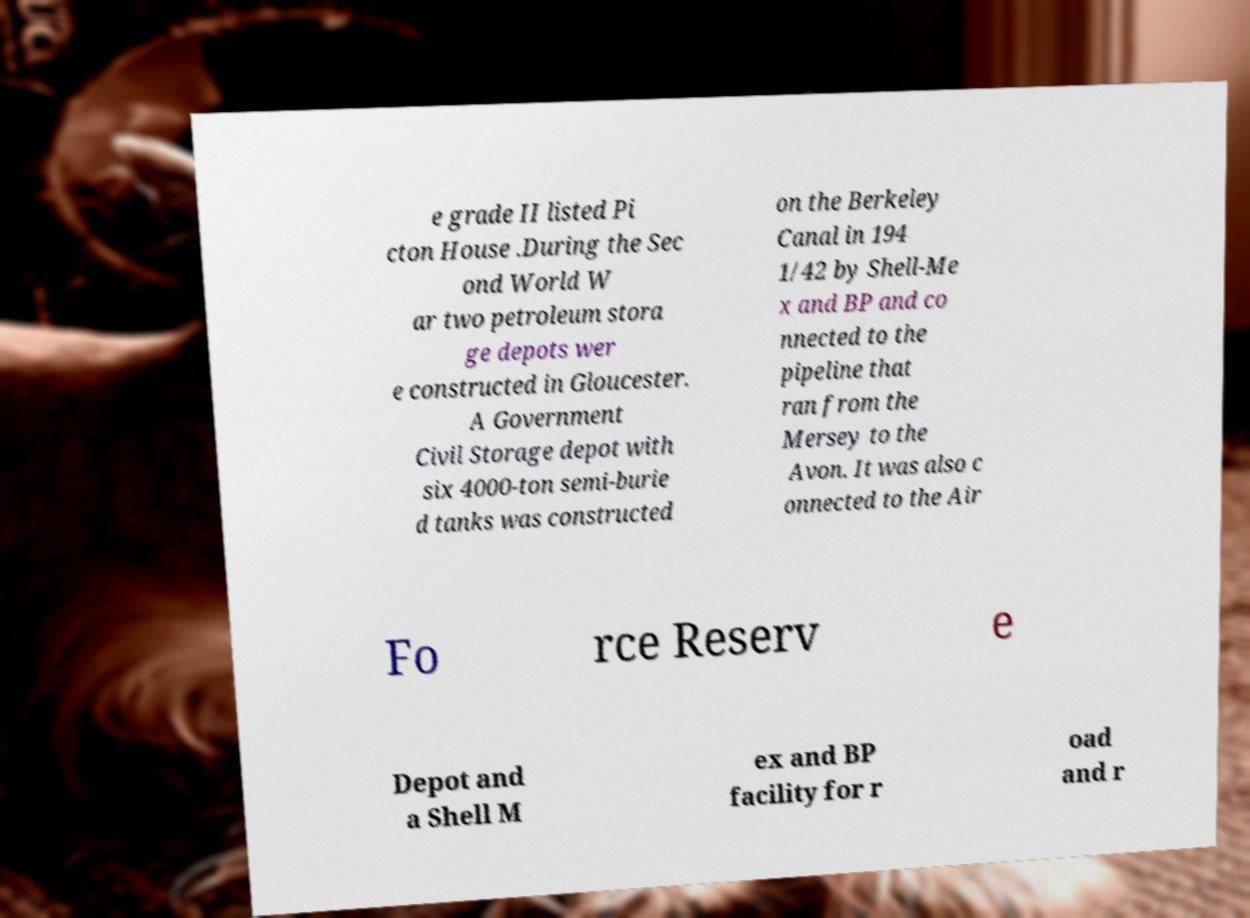There's text embedded in this image that I need extracted. Can you transcribe it verbatim? e grade II listed Pi cton House .During the Sec ond World W ar two petroleum stora ge depots wer e constructed in Gloucester. A Government Civil Storage depot with six 4000-ton semi-burie d tanks was constructed on the Berkeley Canal in 194 1/42 by Shell-Me x and BP and co nnected to the pipeline that ran from the Mersey to the Avon. It was also c onnected to the Air Fo rce Reserv e Depot and a Shell M ex and BP facility for r oad and r 